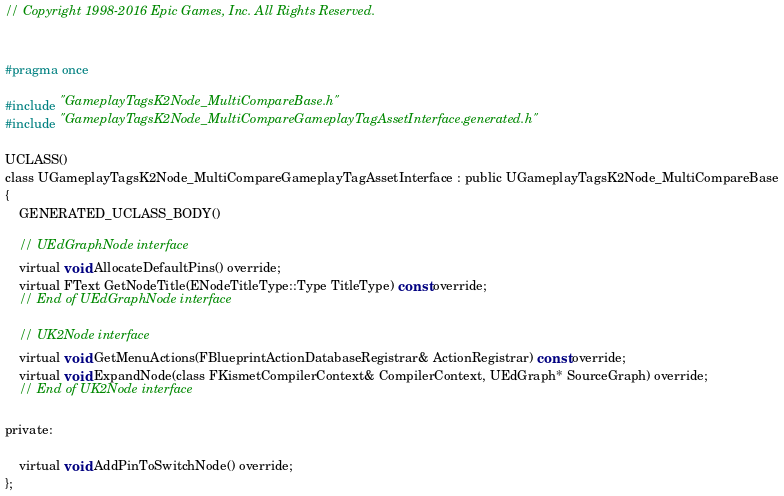Convert code to text. <code><loc_0><loc_0><loc_500><loc_500><_C_>// Copyright 1998-2016 Epic Games, Inc. All Rights Reserved.


#pragma once

#include "GameplayTagsK2Node_MultiCompareBase.h"
#include "GameplayTagsK2Node_MultiCompareGameplayTagAssetInterface.generated.h"

UCLASS()
class UGameplayTagsK2Node_MultiCompareGameplayTagAssetInterface : public UGameplayTagsK2Node_MultiCompareBase
{
	GENERATED_UCLASS_BODY()

	// UEdGraphNode interface
	virtual void AllocateDefaultPins() override;
	virtual FText GetNodeTitle(ENodeTitleType::Type TitleType) const override;
	// End of UEdGraphNode interface

	// UK2Node interface
	virtual void GetMenuActions(FBlueprintActionDatabaseRegistrar& ActionRegistrar) const override;
	virtual void ExpandNode(class FKismetCompilerContext& CompilerContext, UEdGraph* SourceGraph) override;
	// End of UK2Node interface

private:

	virtual void AddPinToSwitchNode() override;
};</code> 